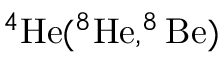<formula> <loc_0><loc_0><loc_500><loc_500>^ { 4 } H e ( ^ { 8 } H e , ^ { 8 } B e )</formula> 